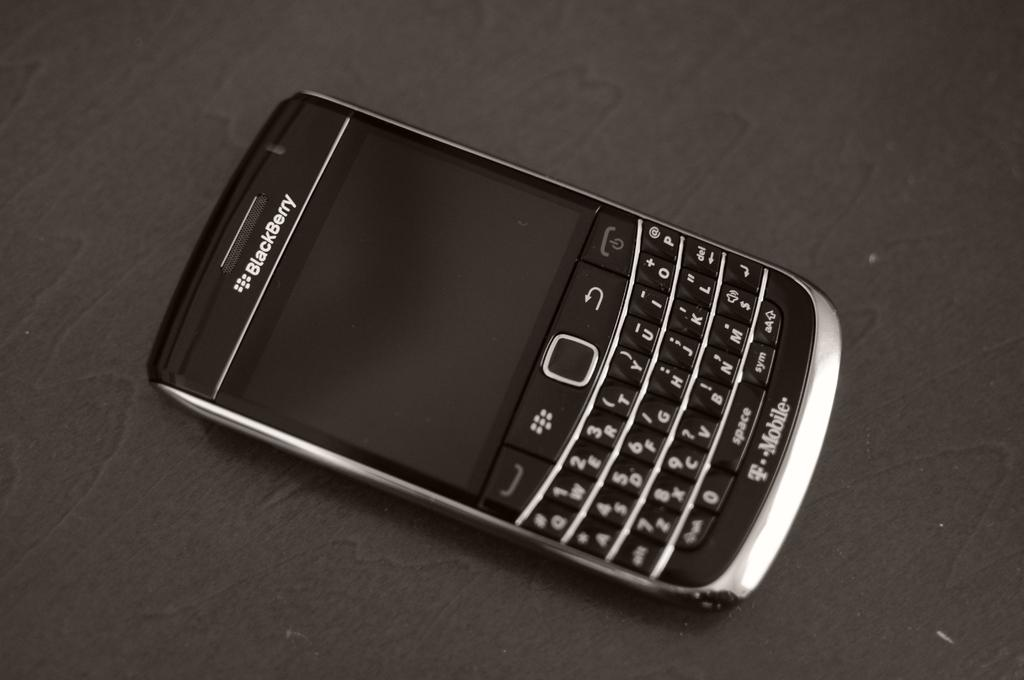<image>
Describe the image concisely. a blackberry phone turned off sitting on a black table 